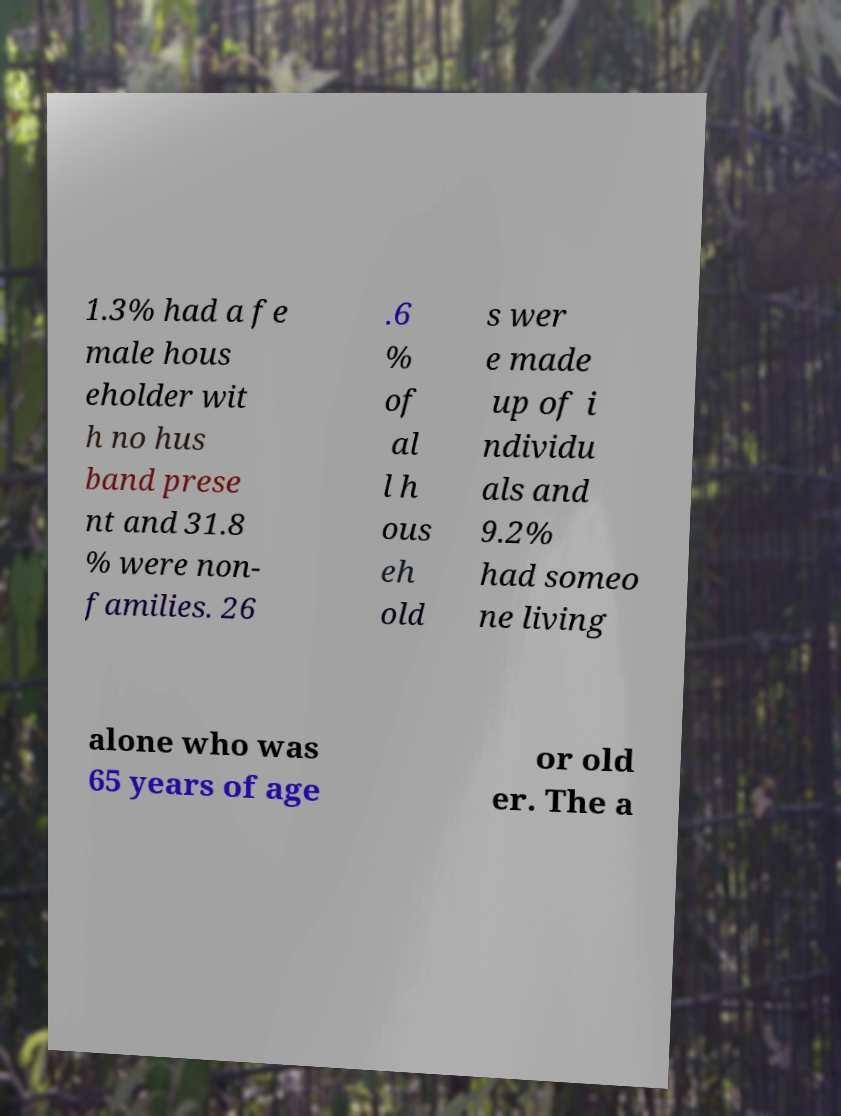Can you accurately transcribe the text from the provided image for me? 1.3% had a fe male hous eholder wit h no hus band prese nt and 31.8 % were non- families. 26 .6 % of al l h ous eh old s wer e made up of i ndividu als and 9.2% had someo ne living alone who was 65 years of age or old er. The a 